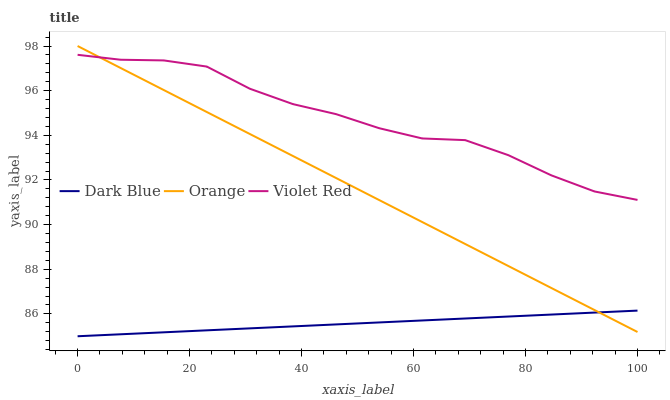Does Violet Red have the minimum area under the curve?
Answer yes or no. No. Does Dark Blue have the maximum area under the curve?
Answer yes or no. No. Is Violet Red the smoothest?
Answer yes or no. No. Is Dark Blue the roughest?
Answer yes or no. No. Does Violet Red have the lowest value?
Answer yes or no. No. Does Violet Red have the highest value?
Answer yes or no. No. Is Dark Blue less than Violet Red?
Answer yes or no. Yes. Is Violet Red greater than Dark Blue?
Answer yes or no. Yes. Does Dark Blue intersect Violet Red?
Answer yes or no. No. 